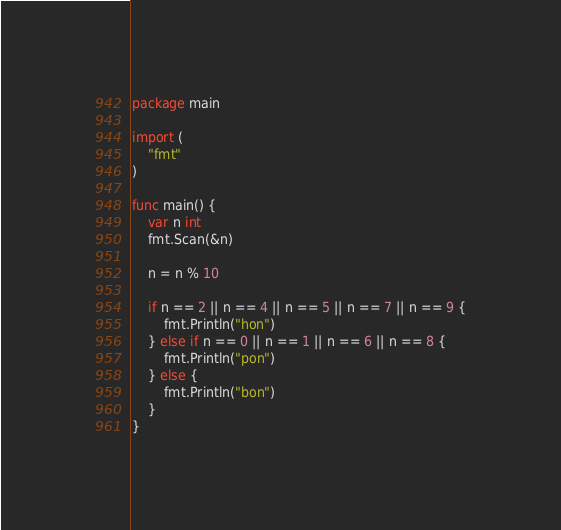Convert code to text. <code><loc_0><loc_0><loc_500><loc_500><_Go_>package main

import (
	"fmt"
)

func main() {
	var n int
	fmt.Scan(&n)

	n = n % 10

	if n == 2 || n == 4 || n == 5 || n == 7 || n == 9 {
		fmt.Println("hon")
	} else if n == 0 || n == 1 || n == 6 || n == 8 {
		fmt.Println("pon")
	} else {
		fmt.Println("bon")
	}
}
</code> 